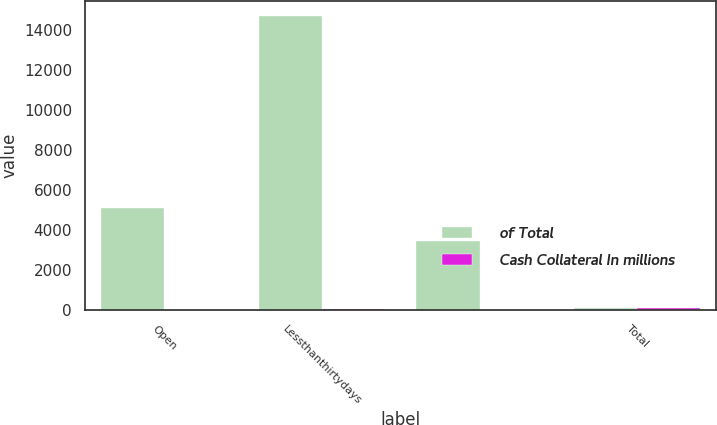<chart> <loc_0><loc_0><loc_500><loc_500><stacked_bar_chart><ecel><fcel>Open<fcel>Lessthanthirtydays<fcel>Unnamed: 3<fcel>Total<nl><fcel>of Total<fcel>5118<fcel>14711<fcel>3471<fcel>100<nl><fcel>Cash Collateral In millions<fcel>22<fcel>63.1<fcel>14.9<fcel>100<nl></chart> 